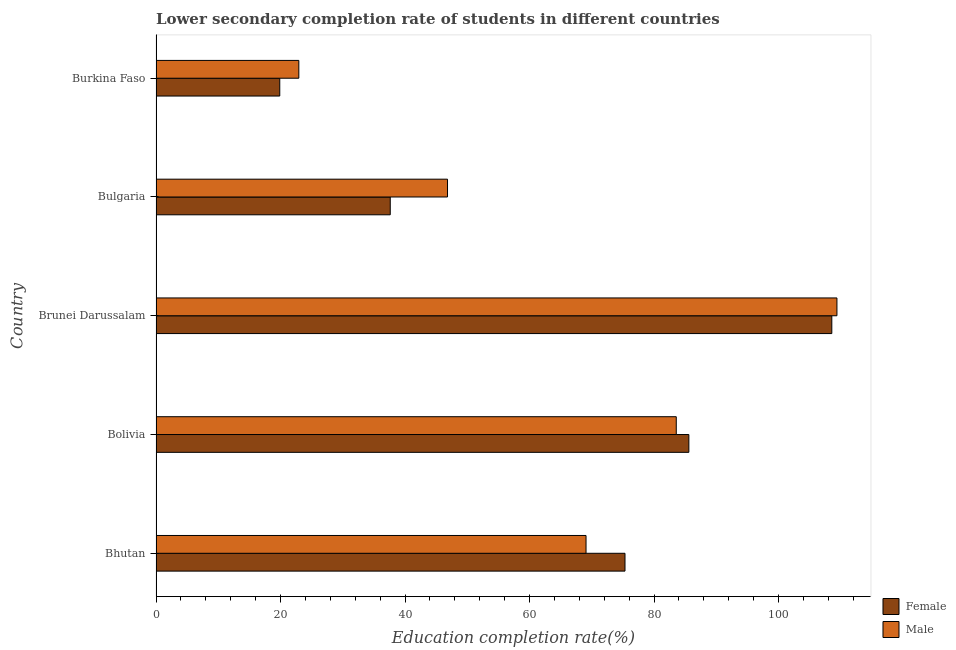How many groups of bars are there?
Your answer should be compact. 5. Are the number of bars on each tick of the Y-axis equal?
Provide a succinct answer. Yes. What is the label of the 3rd group of bars from the top?
Your answer should be very brief. Brunei Darussalam. In how many cases, is the number of bars for a given country not equal to the number of legend labels?
Offer a very short reply. 0. What is the education completion rate of female students in Bolivia?
Give a very brief answer. 85.6. Across all countries, what is the maximum education completion rate of male students?
Give a very brief answer. 109.38. Across all countries, what is the minimum education completion rate of male students?
Give a very brief answer. 22.94. In which country was the education completion rate of female students maximum?
Give a very brief answer. Brunei Darussalam. In which country was the education completion rate of female students minimum?
Offer a terse response. Burkina Faso. What is the total education completion rate of male students in the graph?
Ensure brevity in your answer.  331.81. What is the difference between the education completion rate of female students in Bhutan and that in Burkina Faso?
Make the answer very short. 55.46. What is the difference between the education completion rate of female students in Bolivia and the education completion rate of male students in Burkina Faso?
Make the answer very short. 62.66. What is the average education completion rate of female students per country?
Offer a terse response. 65.4. What is the difference between the education completion rate of male students and education completion rate of female students in Burkina Faso?
Provide a succinct answer. 3.06. In how many countries, is the education completion rate of male students greater than 72 %?
Your answer should be compact. 2. What is the ratio of the education completion rate of male students in Bolivia to that in Bulgaria?
Offer a terse response. 1.78. Is the education completion rate of male students in Bolivia less than that in Bulgaria?
Your answer should be very brief. No. What is the difference between the highest and the second highest education completion rate of female students?
Your answer should be very brief. 22.97. What is the difference between the highest and the lowest education completion rate of female students?
Make the answer very short. 88.68. What does the 2nd bar from the top in Burkina Faso represents?
Provide a succinct answer. Female. What does the 1st bar from the bottom in Burkina Faso represents?
Provide a succinct answer. Female. Are all the bars in the graph horizontal?
Your answer should be compact. Yes. Does the graph contain any zero values?
Offer a terse response. No. Where does the legend appear in the graph?
Give a very brief answer. Bottom right. What is the title of the graph?
Provide a short and direct response. Lower secondary completion rate of students in different countries. What is the label or title of the X-axis?
Make the answer very short. Education completion rate(%). What is the label or title of the Y-axis?
Offer a terse response. Country. What is the Education completion rate(%) in Female in Bhutan?
Keep it short and to the point. 75.34. What is the Education completion rate(%) in Male in Bhutan?
Keep it short and to the point. 69.08. What is the Education completion rate(%) in Female in Bolivia?
Provide a succinct answer. 85.6. What is the Education completion rate(%) in Male in Bolivia?
Your answer should be compact. 83.57. What is the Education completion rate(%) in Female in Brunei Darussalam?
Keep it short and to the point. 108.56. What is the Education completion rate(%) in Male in Brunei Darussalam?
Provide a short and direct response. 109.38. What is the Education completion rate(%) in Female in Bulgaria?
Give a very brief answer. 37.63. What is the Education completion rate(%) in Male in Bulgaria?
Give a very brief answer. 46.83. What is the Education completion rate(%) of Female in Burkina Faso?
Offer a terse response. 19.88. What is the Education completion rate(%) of Male in Burkina Faso?
Your answer should be very brief. 22.94. Across all countries, what is the maximum Education completion rate(%) in Female?
Give a very brief answer. 108.56. Across all countries, what is the maximum Education completion rate(%) of Male?
Your answer should be very brief. 109.38. Across all countries, what is the minimum Education completion rate(%) in Female?
Your answer should be compact. 19.88. Across all countries, what is the minimum Education completion rate(%) of Male?
Offer a very short reply. 22.94. What is the total Education completion rate(%) of Female in the graph?
Ensure brevity in your answer.  327.01. What is the total Education completion rate(%) of Male in the graph?
Your answer should be very brief. 331.81. What is the difference between the Education completion rate(%) in Female in Bhutan and that in Bolivia?
Give a very brief answer. -10.26. What is the difference between the Education completion rate(%) of Male in Bhutan and that in Bolivia?
Keep it short and to the point. -14.49. What is the difference between the Education completion rate(%) of Female in Bhutan and that in Brunei Darussalam?
Offer a terse response. -33.22. What is the difference between the Education completion rate(%) of Male in Bhutan and that in Brunei Darussalam?
Offer a terse response. -40.3. What is the difference between the Education completion rate(%) in Female in Bhutan and that in Bulgaria?
Provide a succinct answer. 37.71. What is the difference between the Education completion rate(%) in Male in Bhutan and that in Bulgaria?
Offer a terse response. 22.25. What is the difference between the Education completion rate(%) in Female in Bhutan and that in Burkina Faso?
Provide a short and direct response. 55.46. What is the difference between the Education completion rate(%) of Male in Bhutan and that in Burkina Faso?
Your answer should be very brief. 46.14. What is the difference between the Education completion rate(%) in Female in Bolivia and that in Brunei Darussalam?
Your answer should be very brief. -22.97. What is the difference between the Education completion rate(%) in Male in Bolivia and that in Brunei Darussalam?
Provide a succinct answer. -25.81. What is the difference between the Education completion rate(%) of Female in Bolivia and that in Bulgaria?
Ensure brevity in your answer.  47.97. What is the difference between the Education completion rate(%) of Male in Bolivia and that in Bulgaria?
Give a very brief answer. 36.75. What is the difference between the Education completion rate(%) in Female in Bolivia and that in Burkina Faso?
Offer a very short reply. 65.72. What is the difference between the Education completion rate(%) in Male in Bolivia and that in Burkina Faso?
Your answer should be very brief. 60.63. What is the difference between the Education completion rate(%) in Female in Brunei Darussalam and that in Bulgaria?
Provide a succinct answer. 70.94. What is the difference between the Education completion rate(%) in Male in Brunei Darussalam and that in Bulgaria?
Offer a terse response. 62.56. What is the difference between the Education completion rate(%) of Female in Brunei Darussalam and that in Burkina Faso?
Keep it short and to the point. 88.68. What is the difference between the Education completion rate(%) in Male in Brunei Darussalam and that in Burkina Faso?
Offer a terse response. 86.44. What is the difference between the Education completion rate(%) of Female in Bulgaria and that in Burkina Faso?
Make the answer very short. 17.75. What is the difference between the Education completion rate(%) in Male in Bulgaria and that in Burkina Faso?
Your answer should be compact. 23.88. What is the difference between the Education completion rate(%) of Female in Bhutan and the Education completion rate(%) of Male in Bolivia?
Provide a succinct answer. -8.24. What is the difference between the Education completion rate(%) of Female in Bhutan and the Education completion rate(%) of Male in Brunei Darussalam?
Ensure brevity in your answer.  -34.05. What is the difference between the Education completion rate(%) of Female in Bhutan and the Education completion rate(%) of Male in Bulgaria?
Your answer should be compact. 28.51. What is the difference between the Education completion rate(%) in Female in Bhutan and the Education completion rate(%) in Male in Burkina Faso?
Your answer should be compact. 52.4. What is the difference between the Education completion rate(%) in Female in Bolivia and the Education completion rate(%) in Male in Brunei Darussalam?
Offer a terse response. -23.79. What is the difference between the Education completion rate(%) of Female in Bolivia and the Education completion rate(%) of Male in Bulgaria?
Give a very brief answer. 38.77. What is the difference between the Education completion rate(%) in Female in Bolivia and the Education completion rate(%) in Male in Burkina Faso?
Offer a terse response. 62.66. What is the difference between the Education completion rate(%) in Female in Brunei Darussalam and the Education completion rate(%) in Male in Bulgaria?
Provide a short and direct response. 61.74. What is the difference between the Education completion rate(%) in Female in Brunei Darussalam and the Education completion rate(%) in Male in Burkina Faso?
Provide a succinct answer. 85.62. What is the difference between the Education completion rate(%) of Female in Bulgaria and the Education completion rate(%) of Male in Burkina Faso?
Keep it short and to the point. 14.69. What is the average Education completion rate(%) in Female per country?
Offer a very short reply. 65.4. What is the average Education completion rate(%) in Male per country?
Your response must be concise. 66.36. What is the difference between the Education completion rate(%) in Female and Education completion rate(%) in Male in Bhutan?
Provide a short and direct response. 6.26. What is the difference between the Education completion rate(%) in Female and Education completion rate(%) in Male in Bolivia?
Your response must be concise. 2.02. What is the difference between the Education completion rate(%) in Female and Education completion rate(%) in Male in Brunei Darussalam?
Keep it short and to the point. -0.82. What is the difference between the Education completion rate(%) of Female and Education completion rate(%) of Male in Bulgaria?
Offer a very short reply. -9.2. What is the difference between the Education completion rate(%) in Female and Education completion rate(%) in Male in Burkina Faso?
Provide a succinct answer. -3.06. What is the ratio of the Education completion rate(%) in Female in Bhutan to that in Bolivia?
Provide a short and direct response. 0.88. What is the ratio of the Education completion rate(%) in Male in Bhutan to that in Bolivia?
Your response must be concise. 0.83. What is the ratio of the Education completion rate(%) of Female in Bhutan to that in Brunei Darussalam?
Keep it short and to the point. 0.69. What is the ratio of the Education completion rate(%) of Male in Bhutan to that in Brunei Darussalam?
Offer a very short reply. 0.63. What is the ratio of the Education completion rate(%) of Female in Bhutan to that in Bulgaria?
Provide a short and direct response. 2. What is the ratio of the Education completion rate(%) in Male in Bhutan to that in Bulgaria?
Provide a succinct answer. 1.48. What is the ratio of the Education completion rate(%) in Female in Bhutan to that in Burkina Faso?
Ensure brevity in your answer.  3.79. What is the ratio of the Education completion rate(%) in Male in Bhutan to that in Burkina Faso?
Your response must be concise. 3.01. What is the ratio of the Education completion rate(%) in Female in Bolivia to that in Brunei Darussalam?
Offer a very short reply. 0.79. What is the ratio of the Education completion rate(%) of Male in Bolivia to that in Brunei Darussalam?
Ensure brevity in your answer.  0.76. What is the ratio of the Education completion rate(%) in Female in Bolivia to that in Bulgaria?
Give a very brief answer. 2.27. What is the ratio of the Education completion rate(%) of Male in Bolivia to that in Bulgaria?
Ensure brevity in your answer.  1.78. What is the ratio of the Education completion rate(%) of Female in Bolivia to that in Burkina Faso?
Your response must be concise. 4.31. What is the ratio of the Education completion rate(%) of Male in Bolivia to that in Burkina Faso?
Provide a succinct answer. 3.64. What is the ratio of the Education completion rate(%) of Female in Brunei Darussalam to that in Bulgaria?
Provide a succinct answer. 2.89. What is the ratio of the Education completion rate(%) of Male in Brunei Darussalam to that in Bulgaria?
Provide a succinct answer. 2.34. What is the ratio of the Education completion rate(%) in Female in Brunei Darussalam to that in Burkina Faso?
Keep it short and to the point. 5.46. What is the ratio of the Education completion rate(%) of Male in Brunei Darussalam to that in Burkina Faso?
Offer a terse response. 4.77. What is the ratio of the Education completion rate(%) of Female in Bulgaria to that in Burkina Faso?
Ensure brevity in your answer.  1.89. What is the ratio of the Education completion rate(%) of Male in Bulgaria to that in Burkina Faso?
Keep it short and to the point. 2.04. What is the difference between the highest and the second highest Education completion rate(%) of Female?
Your response must be concise. 22.97. What is the difference between the highest and the second highest Education completion rate(%) of Male?
Make the answer very short. 25.81. What is the difference between the highest and the lowest Education completion rate(%) in Female?
Provide a short and direct response. 88.68. What is the difference between the highest and the lowest Education completion rate(%) in Male?
Provide a short and direct response. 86.44. 